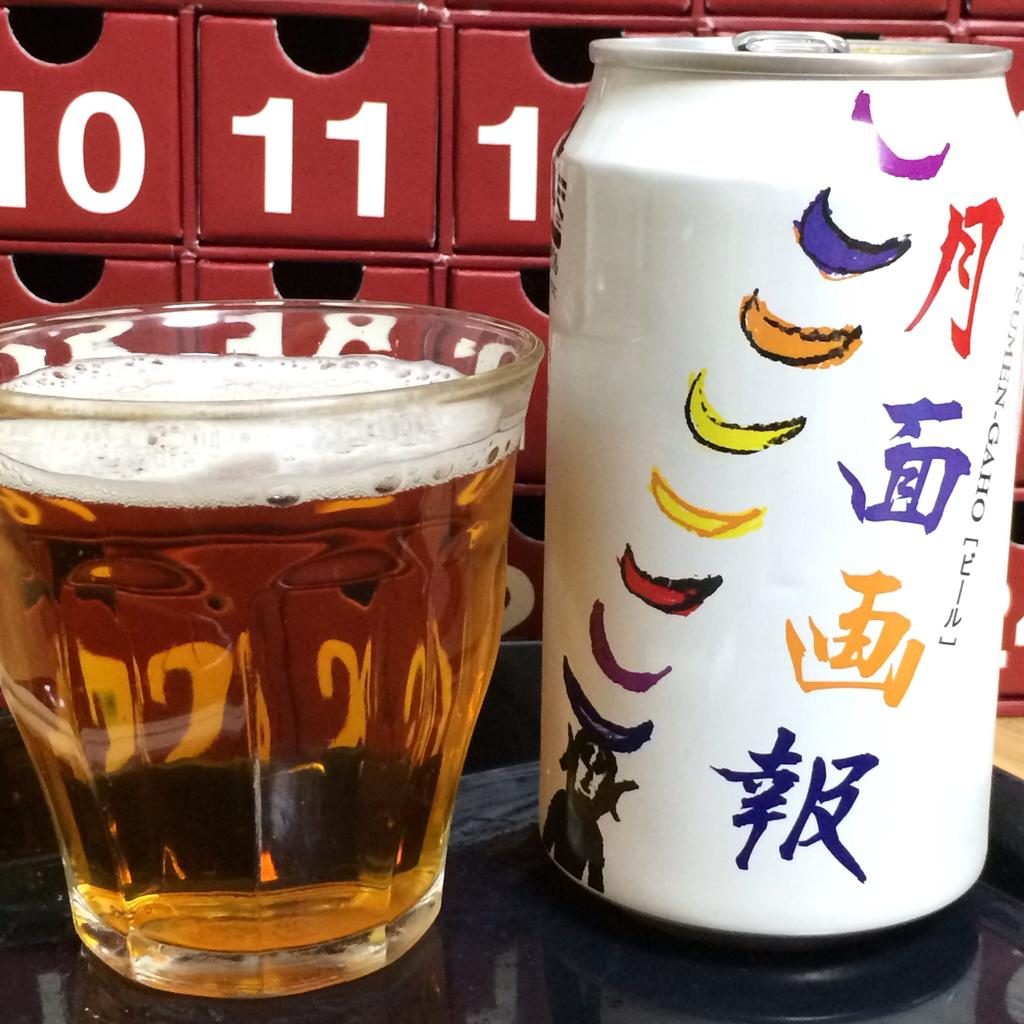<image>
Create a compact narrative representing the image presented. A can of Japanese beer sitting in front of boxes labeled with the numbers 10, 11, 12. 